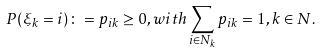Convert formula to latex. <formula><loc_0><loc_0><loc_500><loc_500>P ( \xi _ { k } = i ) \colon = p _ { i k } \geq 0 , w i t h \sum _ { i \in N _ { k } } p _ { i k } = 1 , k \in N .</formula> 